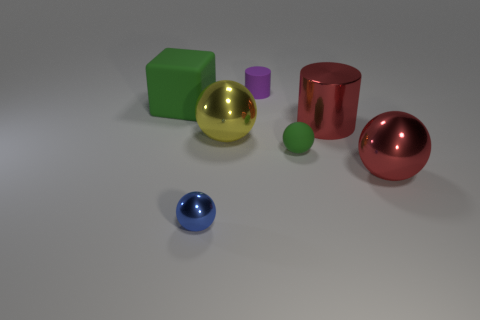What number of matte things have the same color as the tiny cylinder?
Ensure brevity in your answer.  0. What is the size of the block that is made of the same material as the small purple object?
Your response must be concise. Large. How many brown objects are tiny metal spheres or shiny balls?
Give a very brief answer. 0. There is a object that is behind the large green matte block; what number of small matte objects are on the right side of it?
Your answer should be compact. 1. Are there more tiny things that are behind the big shiny cylinder than blue metal balls that are in front of the large green matte object?
Your answer should be compact. No. What is the material of the small blue sphere?
Keep it short and to the point. Metal. Is there another green rubber block of the same size as the block?
Ensure brevity in your answer.  No. What is the material of the blue thing that is the same size as the purple cylinder?
Offer a very short reply. Metal. How many red metallic blocks are there?
Offer a very short reply. 0. What is the size of the matte object on the left side of the large yellow shiny thing?
Your answer should be very brief. Large. 